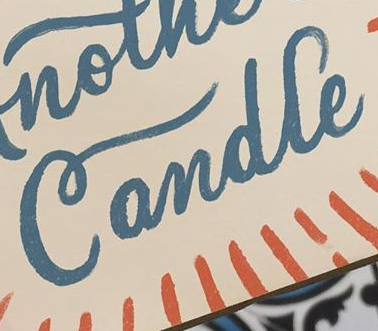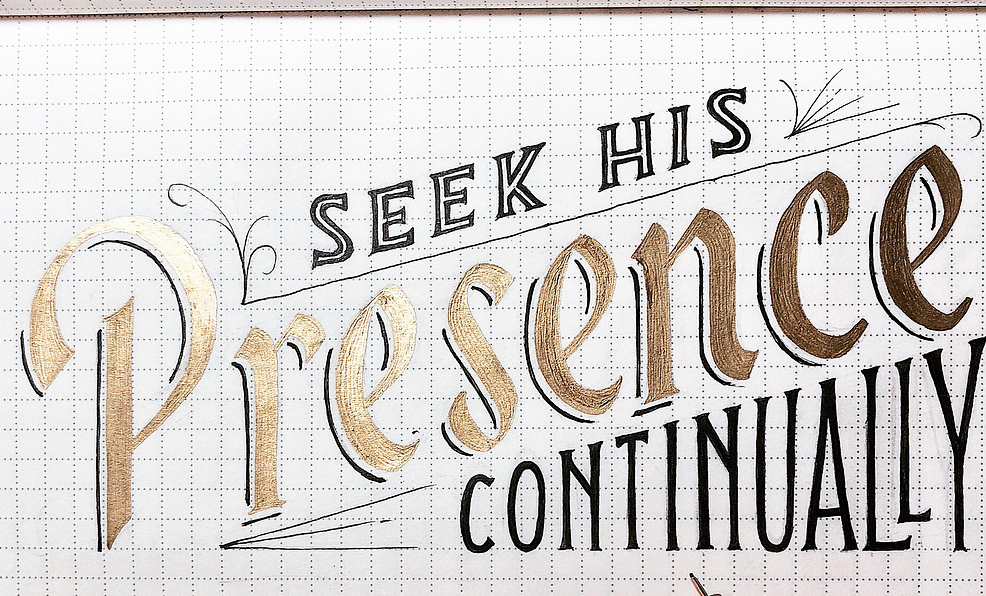What text is displayed in these images sequentially, separated by a semicolon? Candle; Presence 